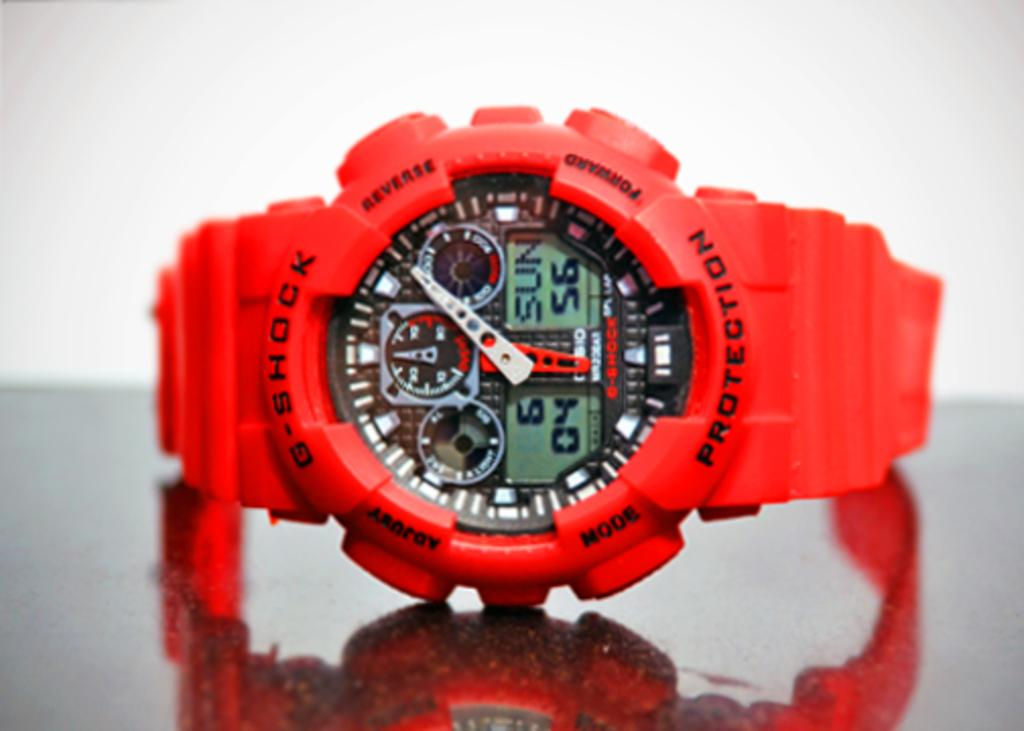Provide a one-sentence caption for the provided image. G shock protection red watch that includes a timer, day, and stop watch. 